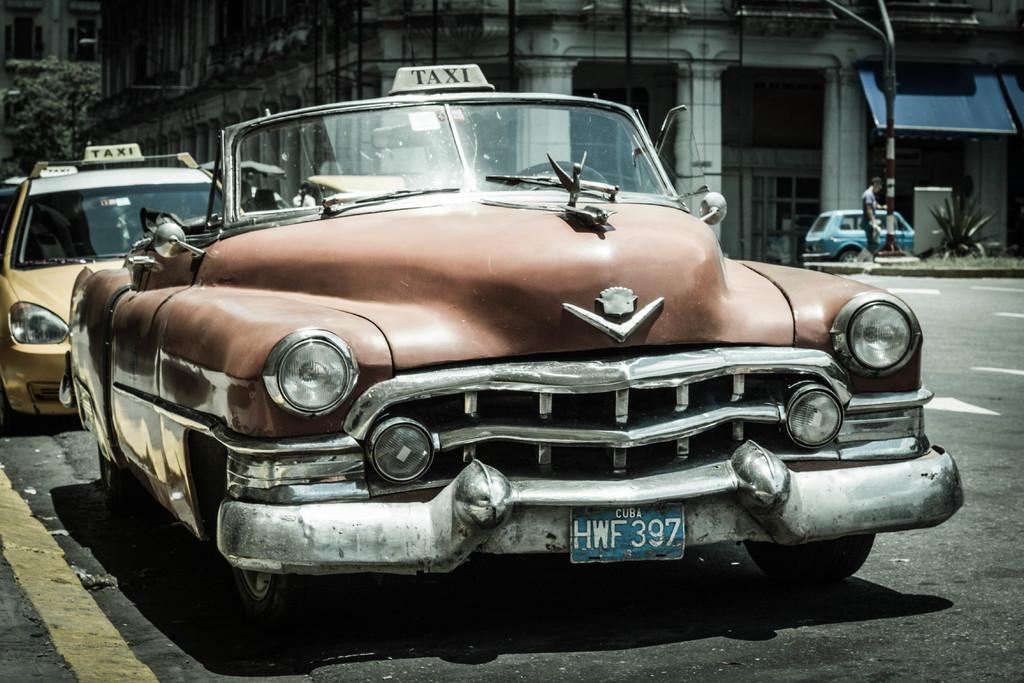What can be seen on the road in the image? There are cars parked on the road in the image. What is visible in the background of the image? There are plants, buildings, and trees in the background of the image. What type of iron can be seen in the image? There is no iron present in the image. How does the cream affect the appearance of the cars in the image? There is no cream present in the image, so it cannot affect the appearance of the cars. 